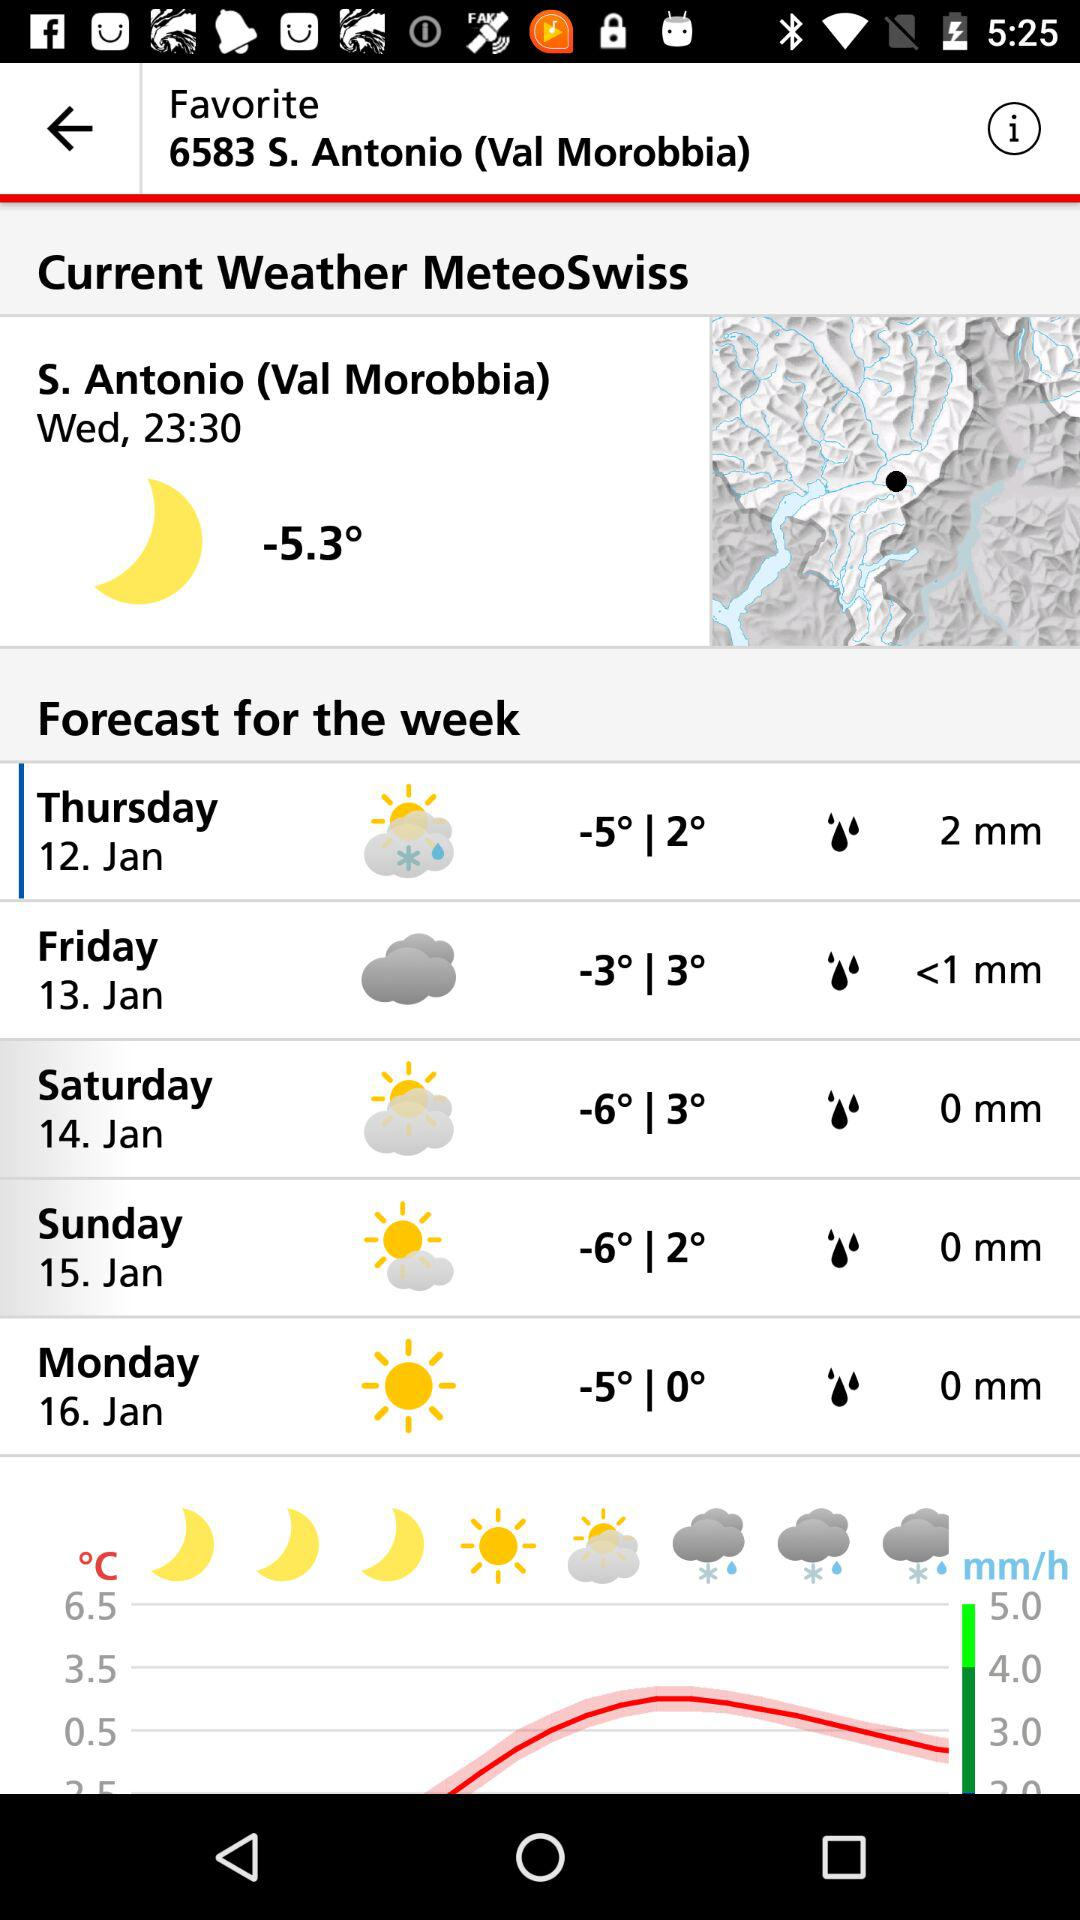What is the temperature reading on January 12? The temperature reading is -5° | 2°. 